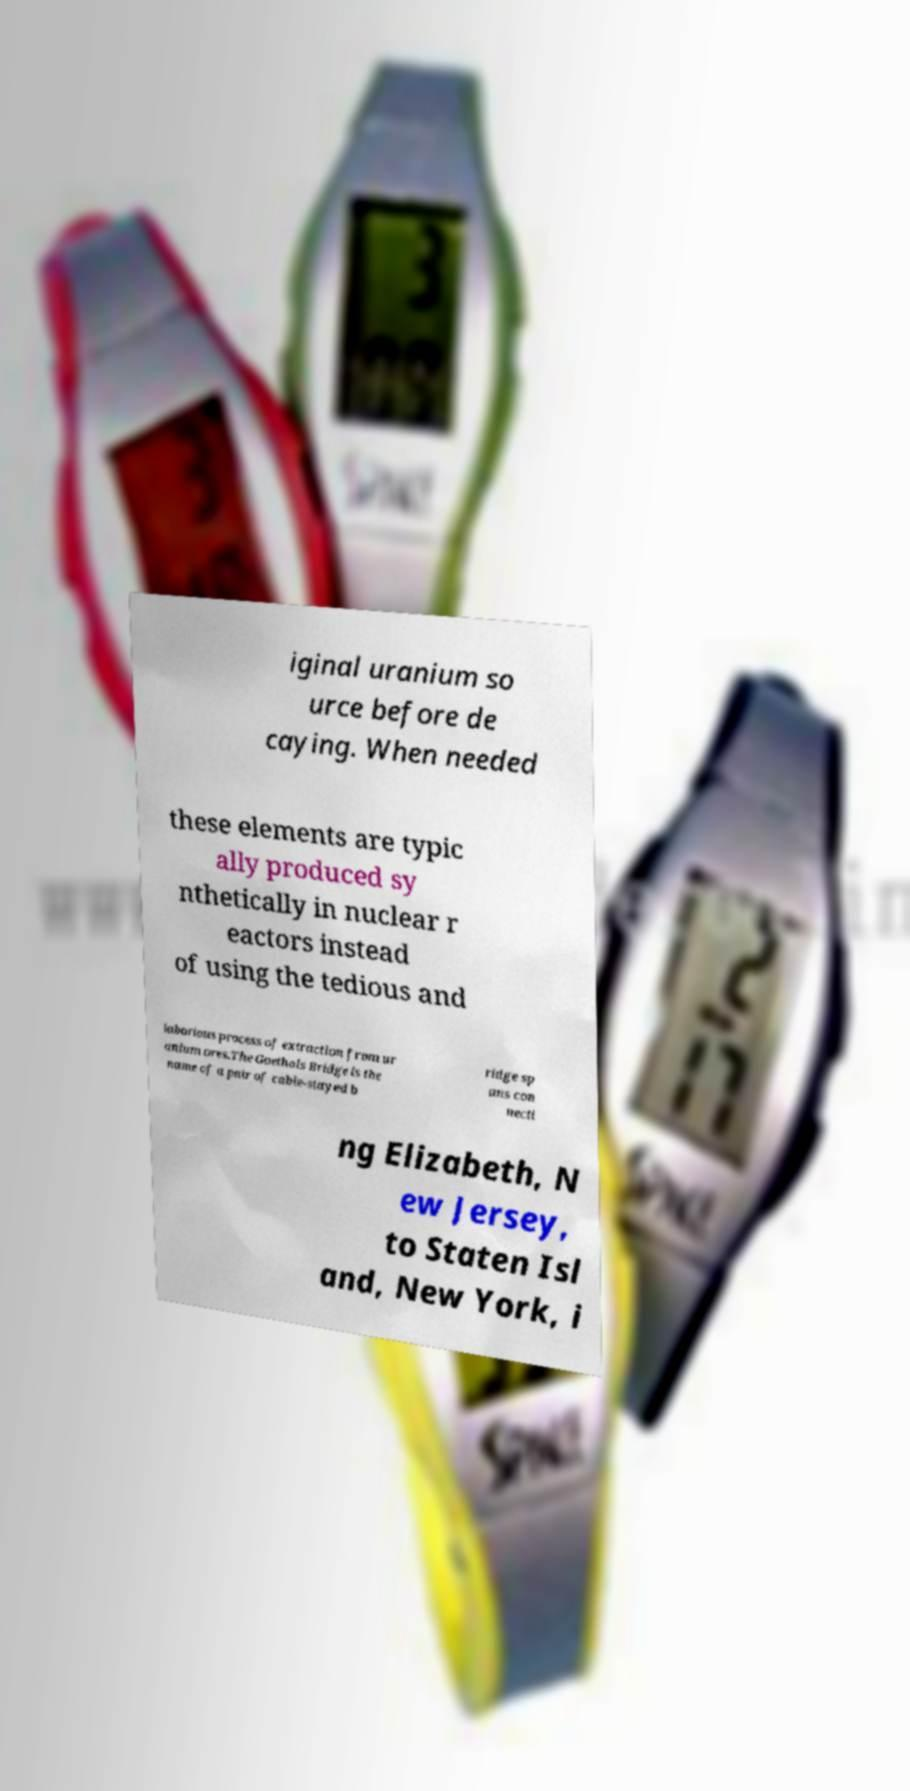Please read and relay the text visible in this image. What does it say? iginal uranium so urce before de caying. When needed these elements are typic ally produced sy nthetically in nuclear r eactors instead of using the tedious and laborious process of extraction from ur anium ores.The Goethals Bridge is the name of a pair of cable-stayed b ridge sp ans con necti ng Elizabeth, N ew Jersey, to Staten Isl and, New York, i 